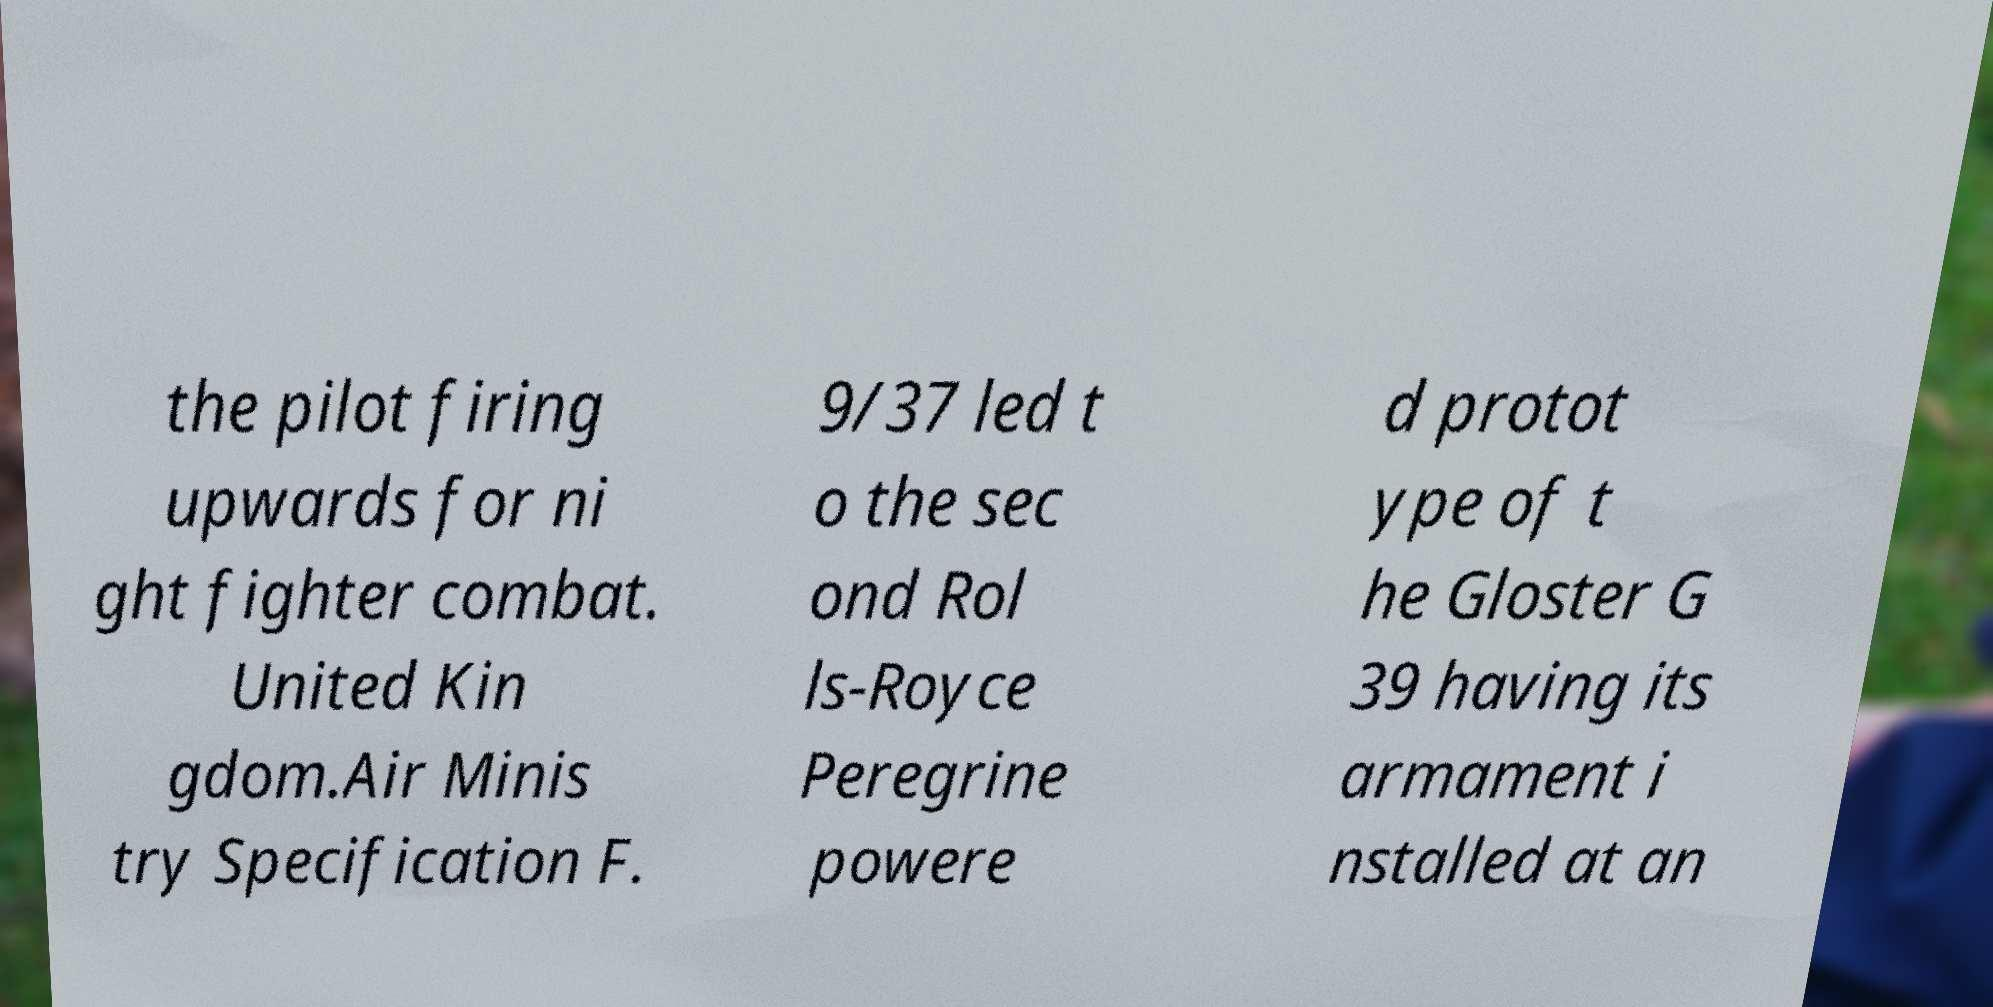For documentation purposes, I need the text within this image transcribed. Could you provide that? the pilot firing upwards for ni ght fighter combat. United Kin gdom.Air Minis try Specification F. 9/37 led t o the sec ond Rol ls-Royce Peregrine powere d protot ype of t he Gloster G 39 having its armament i nstalled at an 